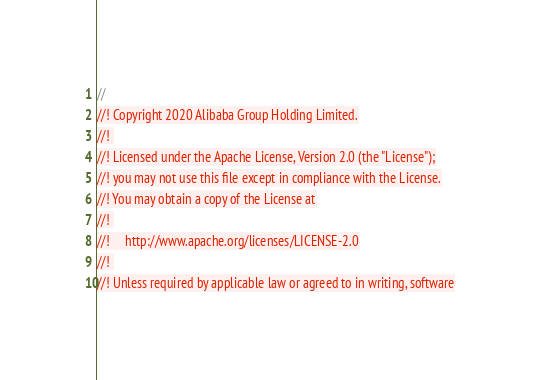<code> <loc_0><loc_0><loc_500><loc_500><_Rust_>//
//! Copyright 2020 Alibaba Group Holding Limited.
//! 
//! Licensed under the Apache License, Version 2.0 (the "License");
//! you may not use this file except in compliance with the License.
//! You may obtain a copy of the License at
//! 
//!     http://www.apache.org/licenses/LICENSE-2.0
//! 
//! Unless required by applicable law or agreed to in writing, software</code> 